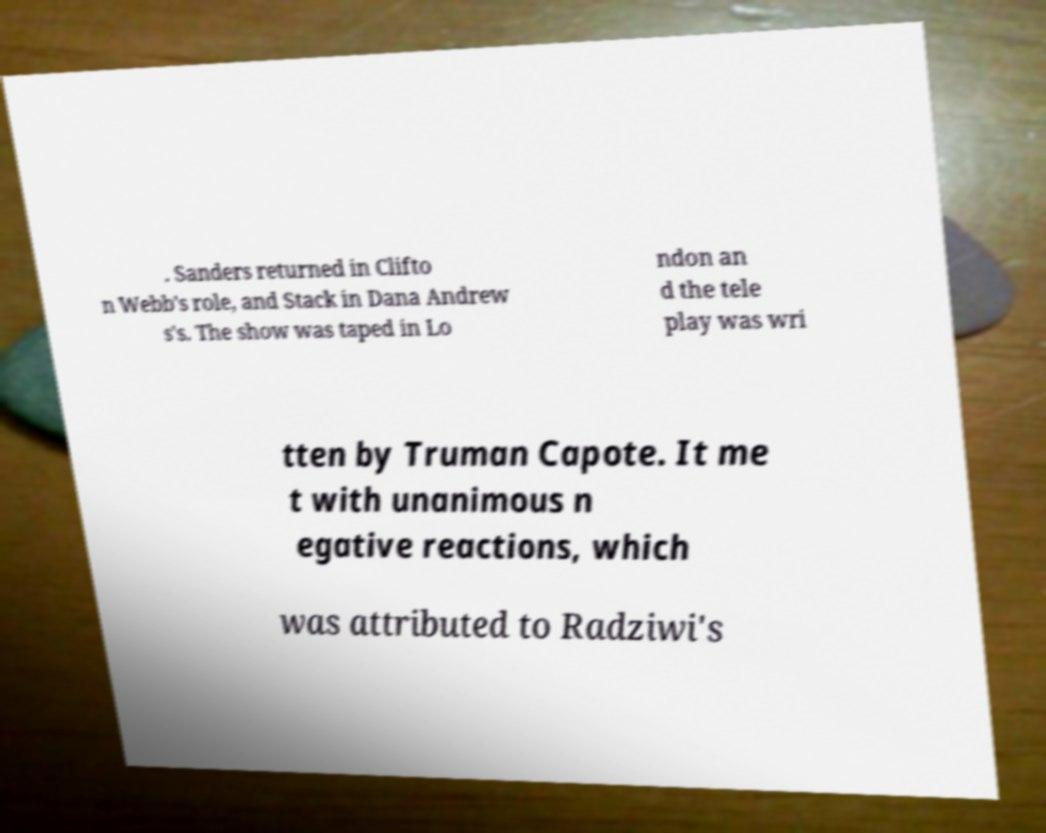Please read and relay the text visible in this image. What does it say? . Sanders returned in Clifto n Webb's role, and Stack in Dana Andrew s's. The show was taped in Lo ndon an d the tele play was wri tten by Truman Capote. It me t with unanimous n egative reactions, which was attributed to Radziwi's 